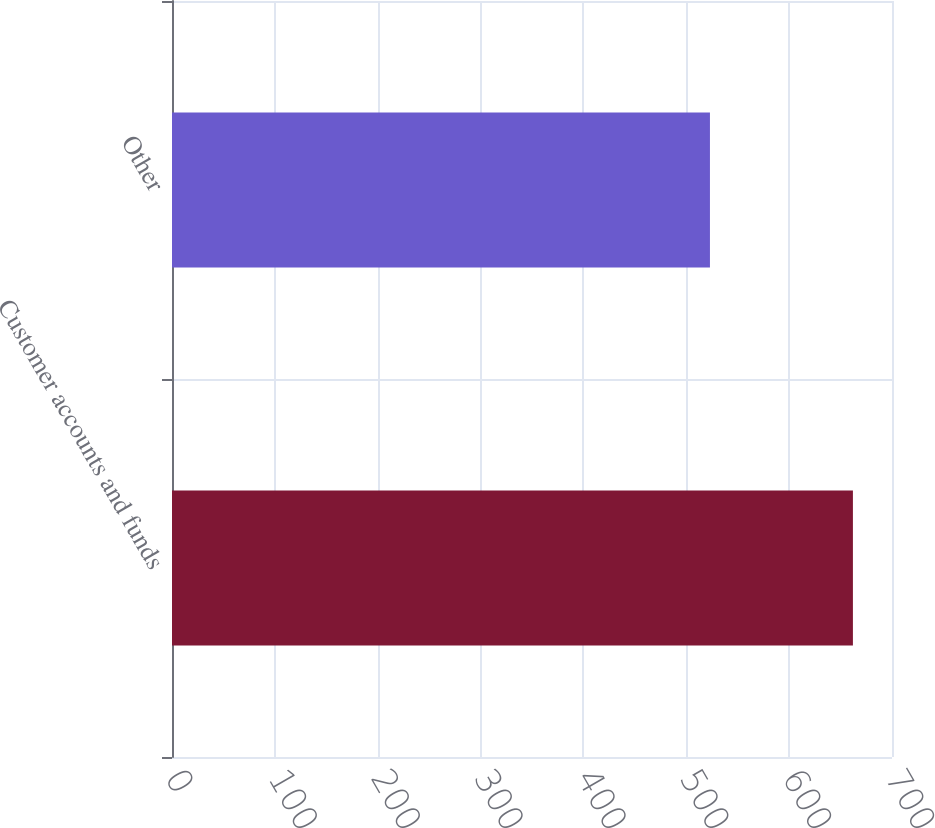Convert chart. <chart><loc_0><loc_0><loc_500><loc_500><bar_chart><fcel>Customer accounts and funds<fcel>Other<nl><fcel>662<fcel>523<nl></chart> 